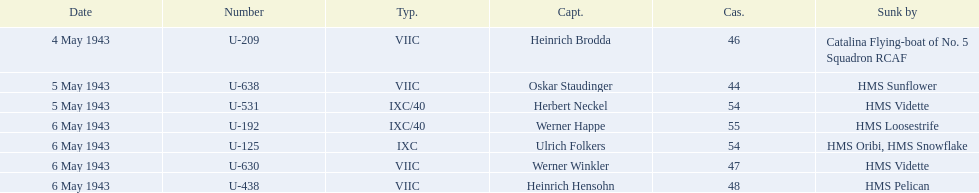Can you give me this table as a dict? {'header': ['Date', 'Number', 'Typ.', 'Capt.', 'Cas.', 'Sunk by'], 'rows': [['4 May 1943', 'U-209', 'VIIC', 'Heinrich Brodda', '46', 'Catalina Flying-boat of No. 5 Squadron RCAF'], ['5 May 1943', 'U-638', 'VIIC', 'Oskar Staudinger', '44', 'HMS Sunflower'], ['5 May 1943', 'U-531', 'IXC/40', 'Herbert Neckel', '54', 'HMS Vidette'], ['6 May 1943', 'U-192', 'IXC/40', 'Werner Happe', '55', 'HMS Loosestrife'], ['6 May 1943', 'U-125', 'IXC', 'Ulrich Folkers', '54', 'HMS Oribi, HMS Snowflake'], ['6 May 1943', 'U-630', 'VIIC', 'Werner Winkler', '47', 'HMS Vidette'], ['6 May 1943', 'U-438', 'VIIC', 'Heinrich Hensohn', '48', 'HMS Pelican']]} What is the list of ships under sunk by? Catalina Flying-boat of No. 5 Squadron RCAF, HMS Sunflower, HMS Vidette, HMS Loosestrife, HMS Oribi, HMS Snowflake, HMS Vidette, HMS Pelican. Which captains did hms pelican sink? Heinrich Hensohn. 